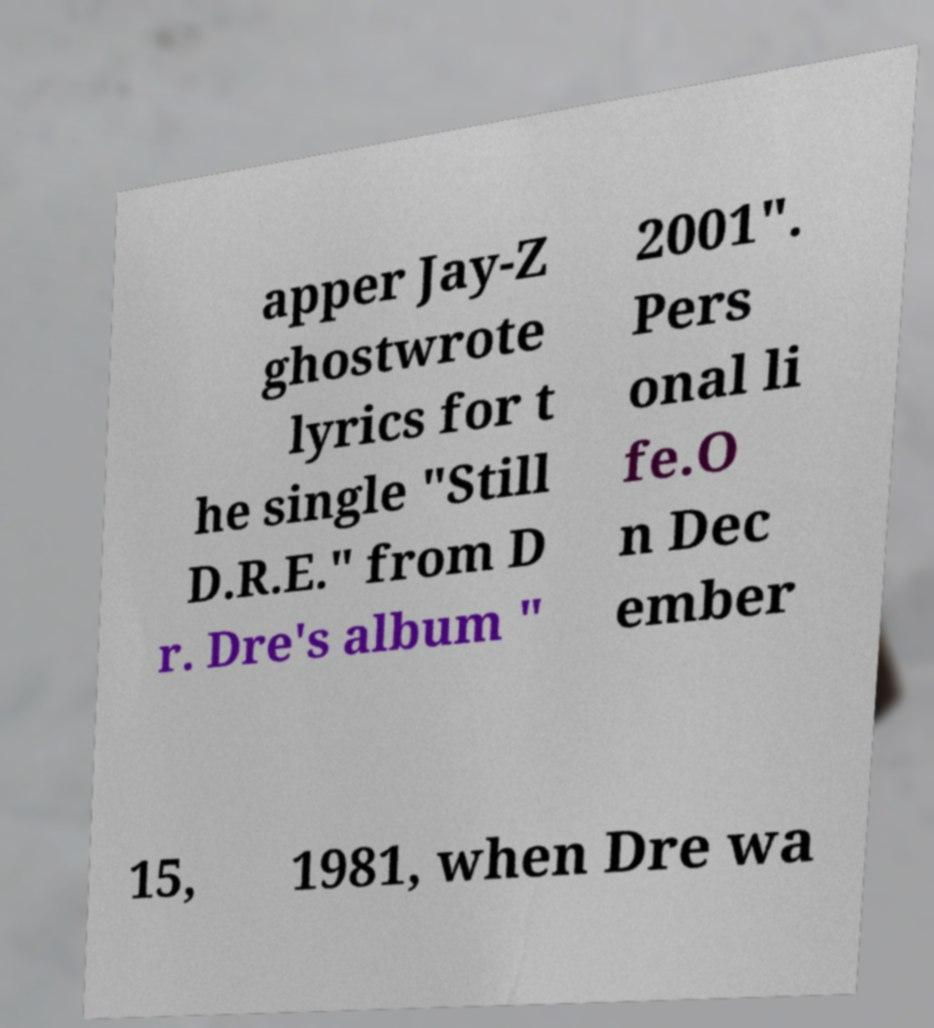What messages or text are displayed in this image? I need them in a readable, typed format. apper Jay-Z ghostwrote lyrics for t he single "Still D.R.E." from D r. Dre's album " 2001". Pers onal li fe.O n Dec ember 15, 1981, when Dre wa 